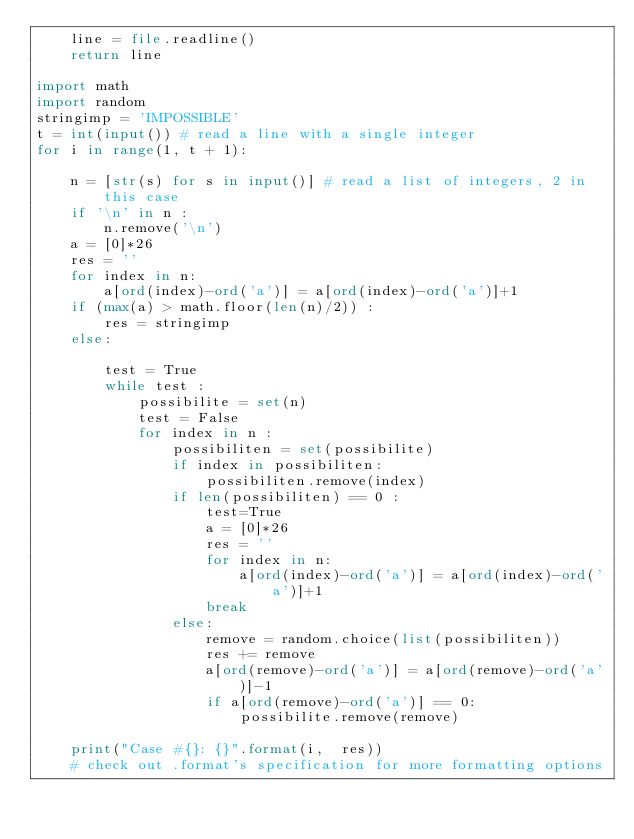Convert code to text. <code><loc_0><loc_0><loc_500><loc_500><_Python_>    line = file.readline()
    return line

import math
import random
stringimp = 'IMPOSSIBLE'
t = int(input()) # read a line with a single integer
for i in range(1, t + 1):

    n = [str(s) for s in input()] # read a list of integers, 2 in this case
    if '\n' in n :
        n.remove('\n')
    a = [0]*26
    res = ''
    for index in n:
        a[ord(index)-ord('a')] = a[ord(index)-ord('a')]+1
    if (max(a) > math.floor(len(n)/2)) :
        res = stringimp
    else:
       
        test = True
        while test :
            possibilite = set(n)
            test = False
            for index in n :
                possibiliten = set(possibilite)
                if index in possibiliten:
                    possibiliten.remove(index)
                if len(possibiliten) == 0 :
                    test=True
                    a = [0]*26
                    res = ''
                    for index in n:
                        a[ord(index)-ord('a')] = a[ord(index)-ord('a')]+1
                    break
                else:
                    remove = random.choice(list(possibiliten))
                    res += remove
                    a[ord(remove)-ord('a')] = a[ord(remove)-ord('a')]-1
                    if a[ord(remove)-ord('a')] == 0:
                        possibilite.remove(remove)

    print("Case #{}: {}".format(i,  res))
    # check out .format's specification for more formatting options</code> 